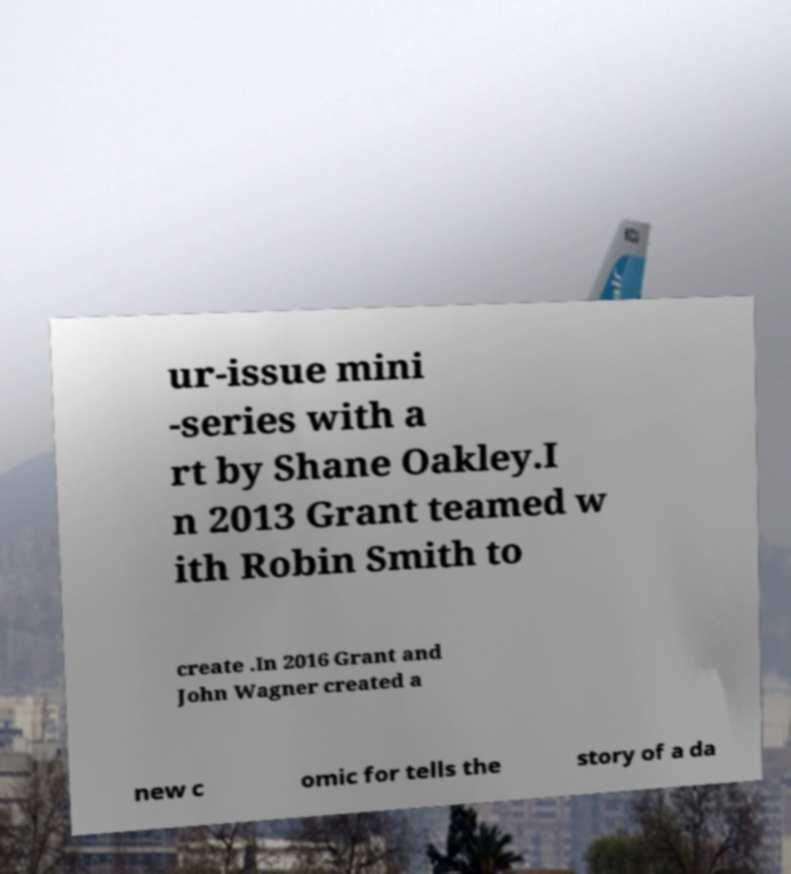Could you extract and type out the text from this image? ur-issue mini -series with a rt by Shane Oakley.I n 2013 Grant teamed w ith Robin Smith to create .In 2016 Grant and John Wagner created a new c omic for tells the story of a da 